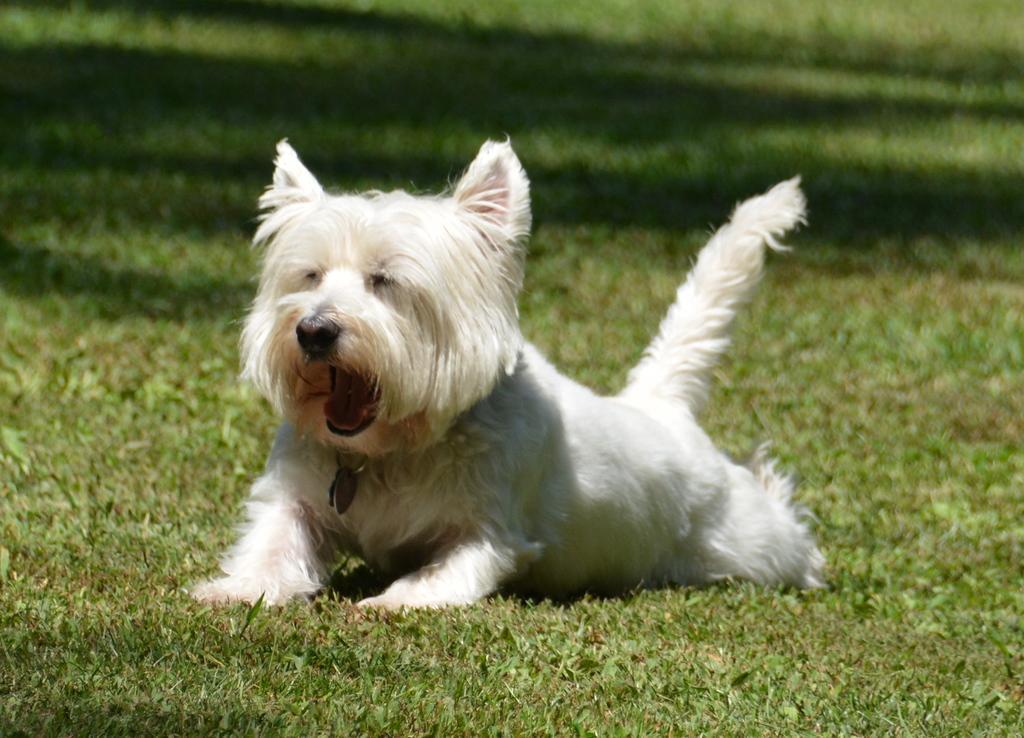Please provide a concise description of this image. In this picture there is a dog which is in white color is on a greenery ground. 